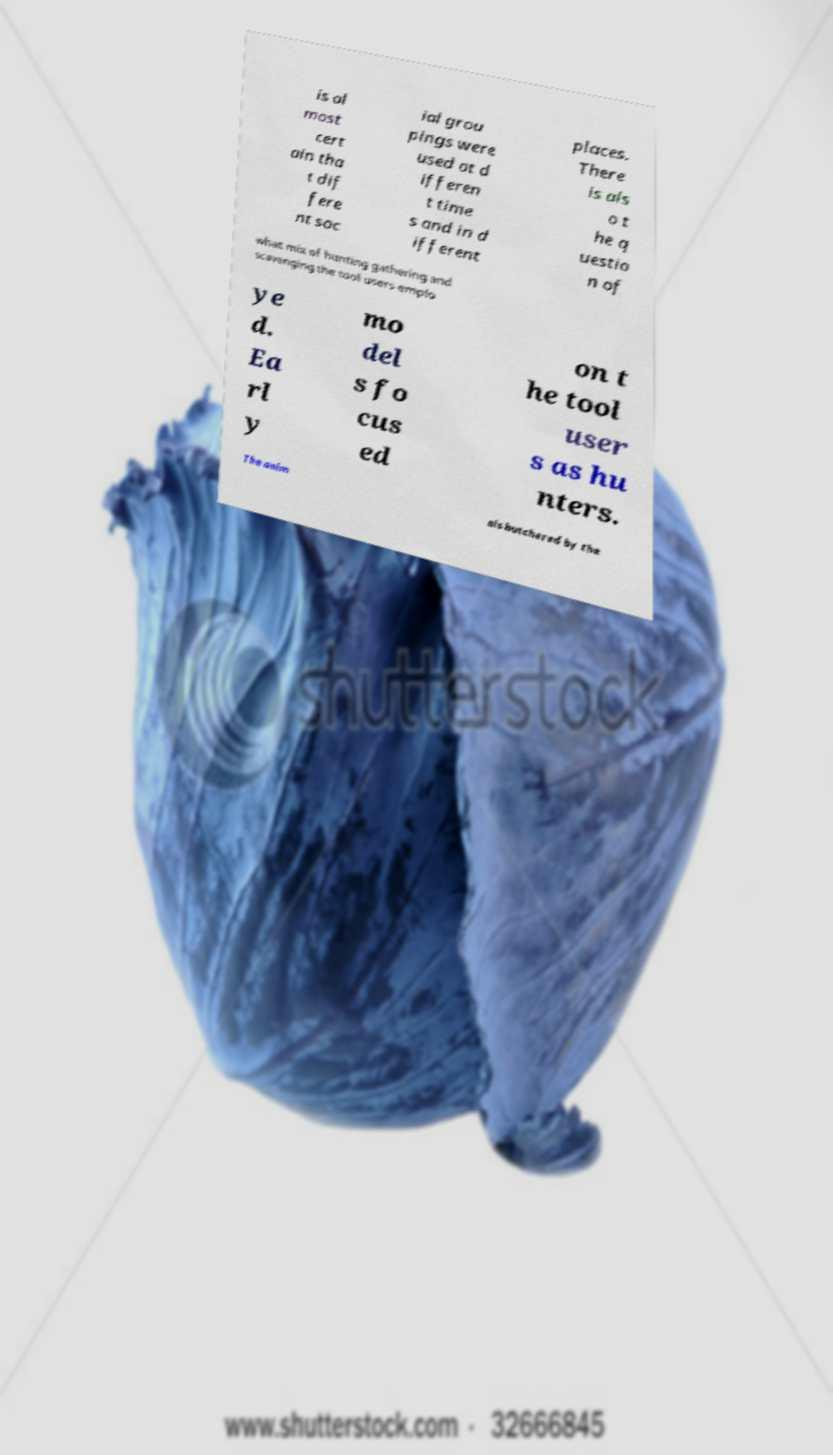Can you accurately transcribe the text from the provided image for me? is al most cert ain tha t dif fere nt soc ial grou pings were used at d ifferen t time s and in d ifferent places. There is als o t he q uestio n of what mix of hunting gathering and scavenging the tool users emplo ye d. Ea rl y mo del s fo cus ed on t he tool user s as hu nters. The anim als butchered by the 